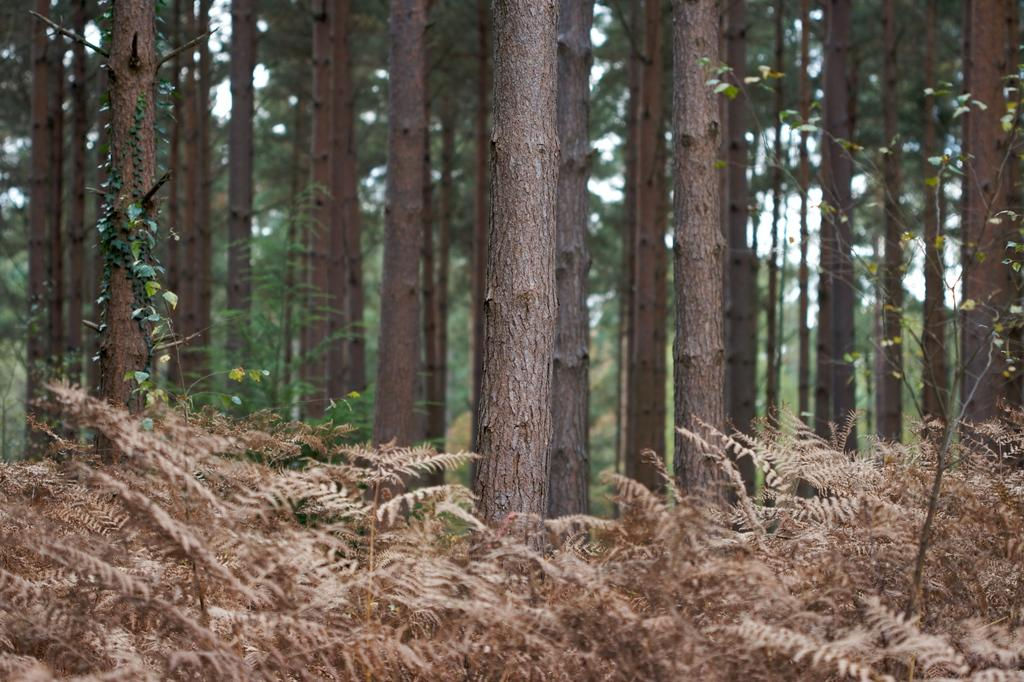What type of vegetation can be seen in the image? There are trees and plants in the image. What part of the natural environment is visible in the image? The sky is visible in the background of the image. Can you describe the vegetation in more detail? The trees and plants in the image appear to be green and leafy. How does the liquid in the image help to lift the trees? There is no liquid present in the image, and therefore it cannot help to lift the trees. 